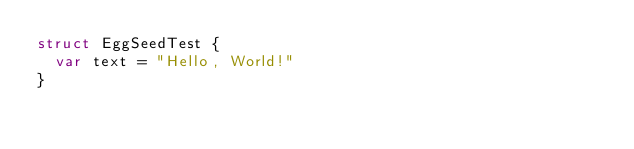Convert code to text. <code><loc_0><loc_0><loc_500><loc_500><_Swift_>struct EggSeedTest {
  var text = "Hello, World!"
}
</code> 